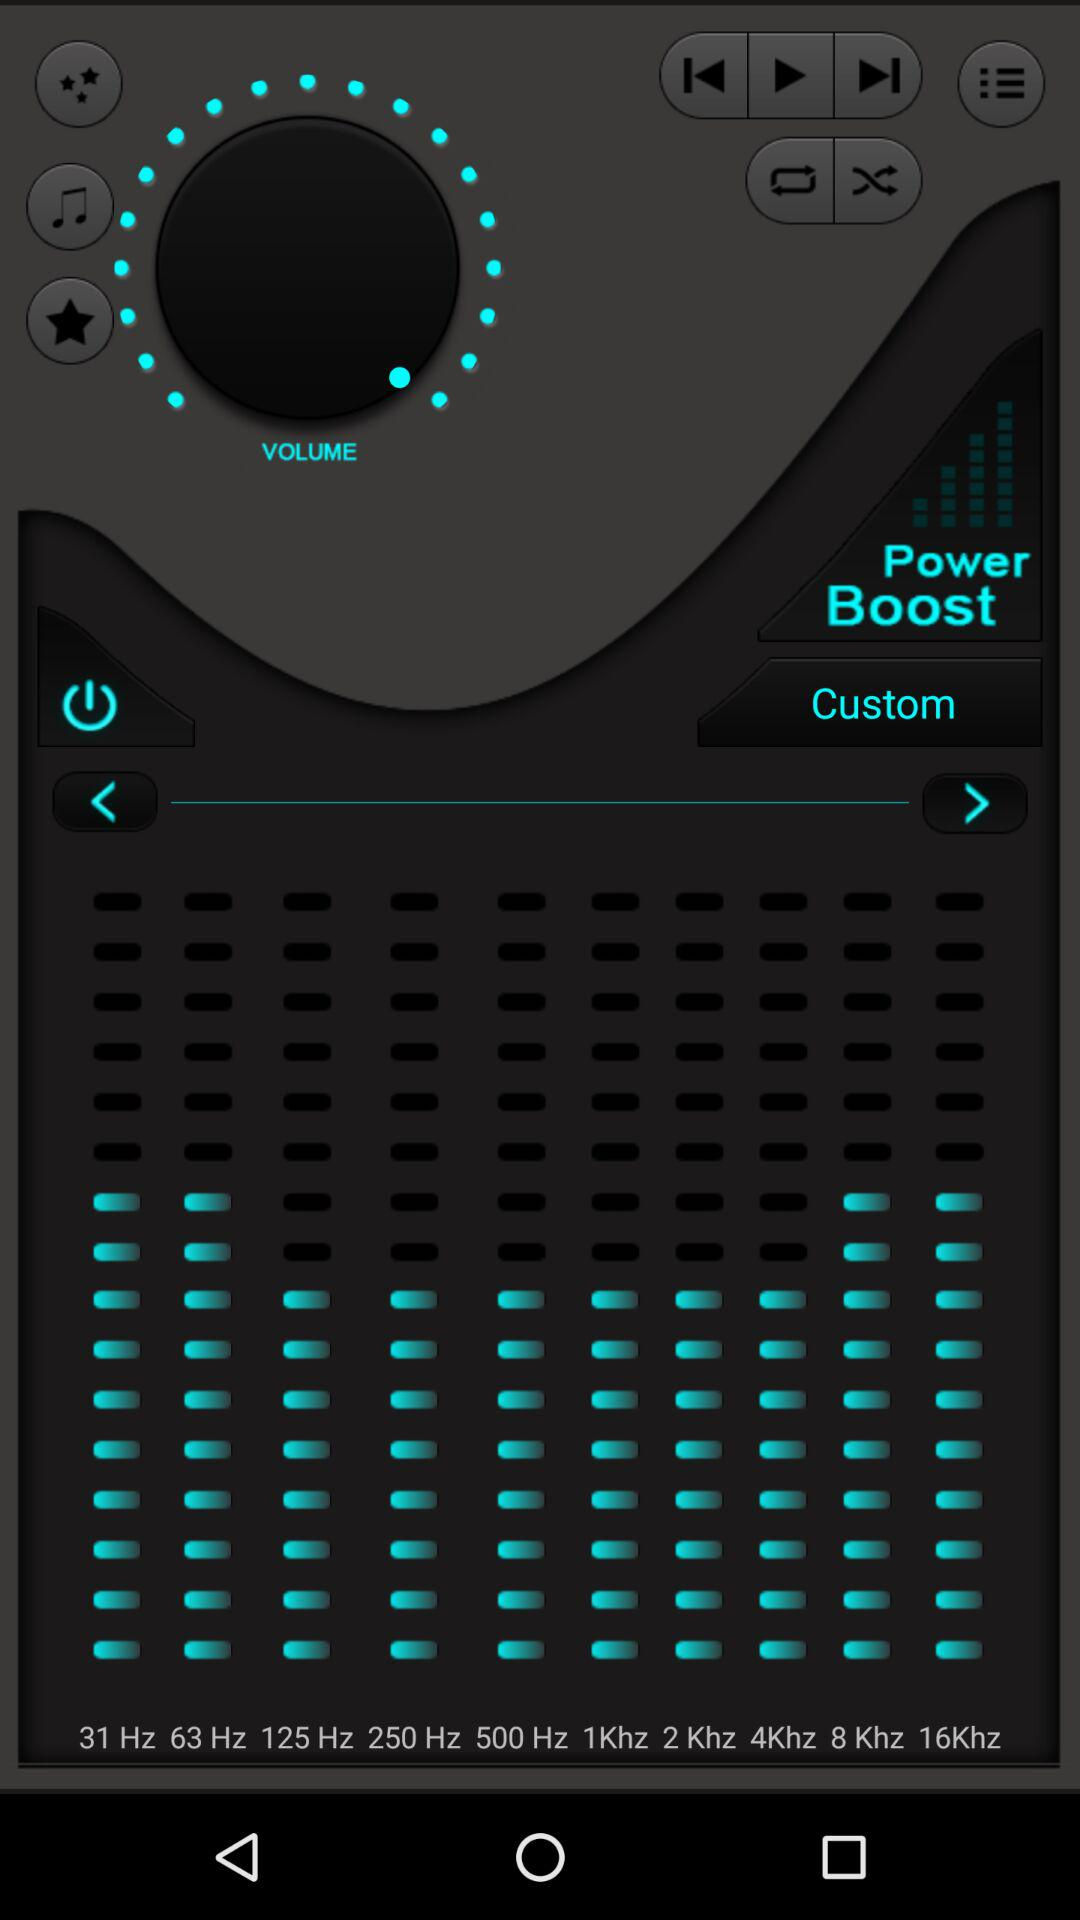How many frequency options are there?
Answer the question using a single word or phrase. 10 